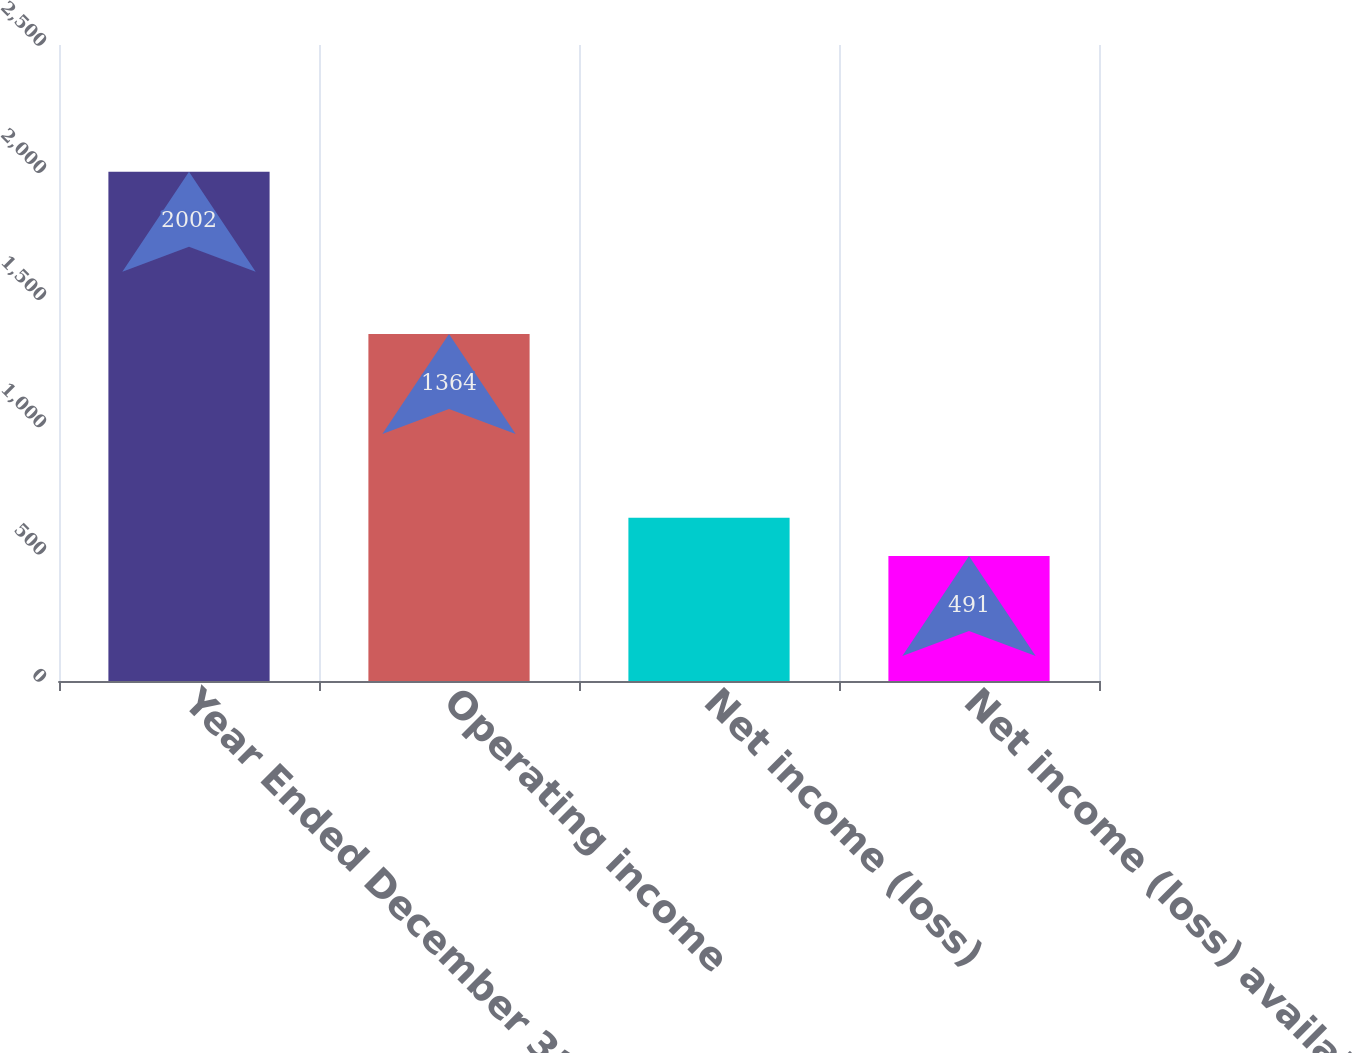Convert chart to OTSL. <chart><loc_0><loc_0><loc_500><loc_500><bar_chart><fcel>Year Ended December 31<fcel>Operating income<fcel>Net income (loss)<fcel>Net income (loss) available to<nl><fcel>2002<fcel>1364<fcel>642.1<fcel>491<nl></chart> 